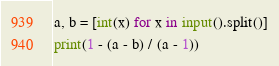Convert code to text. <code><loc_0><loc_0><loc_500><loc_500><_Python_>a, b = [int(x) for x in input().split()]
print(1 - (a - b) / (a - 1))</code> 